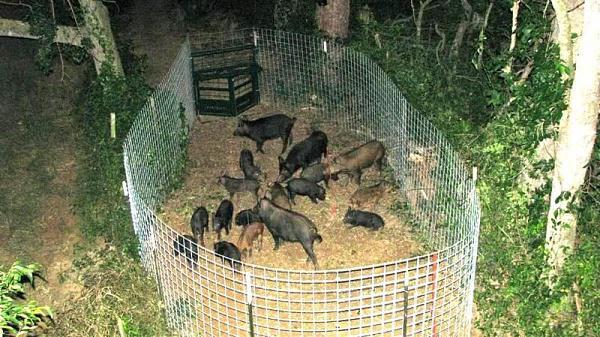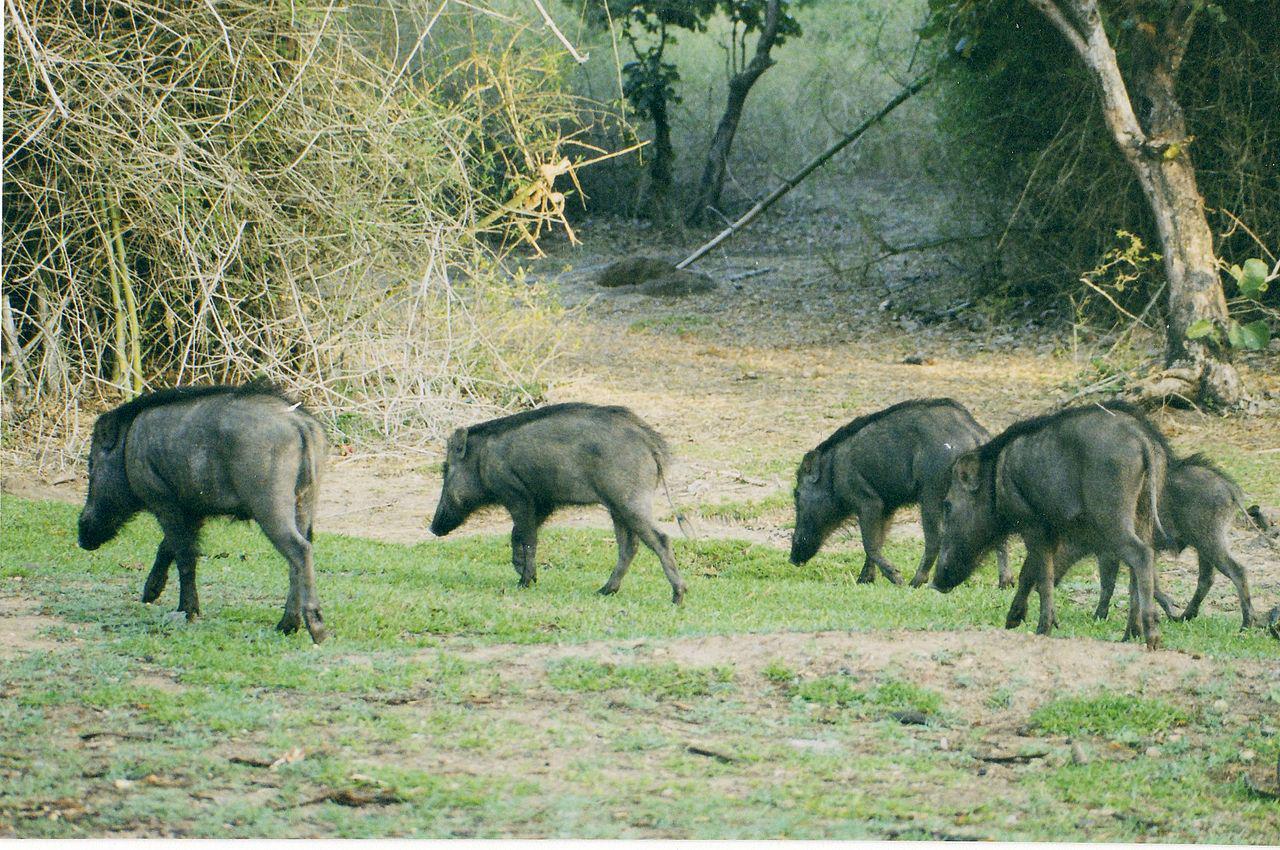The first image is the image on the left, the second image is the image on the right. For the images shown, is this caption "the right image contains no more than five boars." true? Answer yes or no. Yes. The first image is the image on the left, the second image is the image on the right. Considering the images on both sides, is "In the image on the right all of the warthogs are walking to the left." valid? Answer yes or no. Yes. 